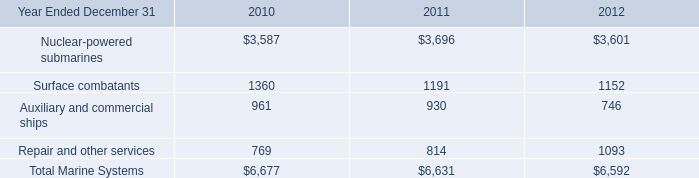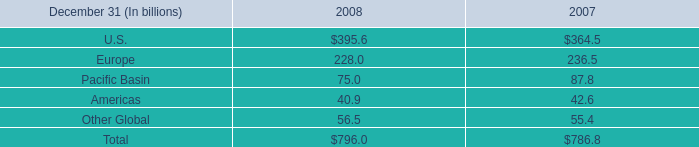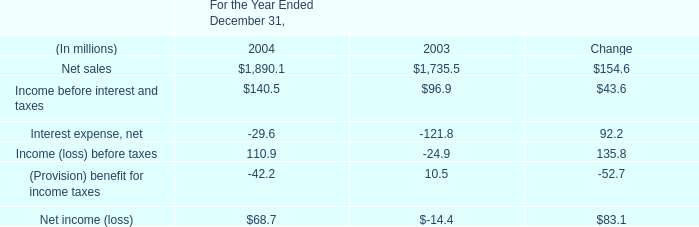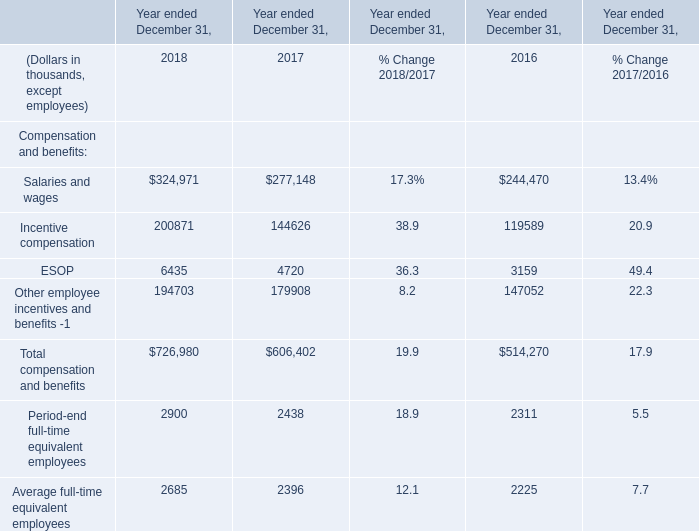What's the growth rate of Total compensation and benefits in 2017 ended December 31? 
Computations: ((606402 - 514270) / 514270)
Answer: 0.17915. 